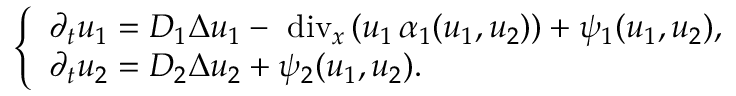<formula> <loc_0><loc_0><loc_500><loc_500>\left \{ \begin{array} { l } { \partial _ { t } u _ { 1 } = D _ { 1 } \Delta u _ { 1 } - \mathrm { d i v } _ { x } \, ( u _ { 1 } \, \alpha _ { 1 } ( u _ { 1 } , u _ { 2 } ) ) + \psi _ { 1 } ( u _ { 1 } , u _ { 2 } ) , } \\ { \partial _ { t } u _ { 2 } = D _ { 2 } \Delta u _ { 2 } + \psi _ { 2 } ( u _ { 1 } , u _ { 2 } ) . } \end{array}</formula> 